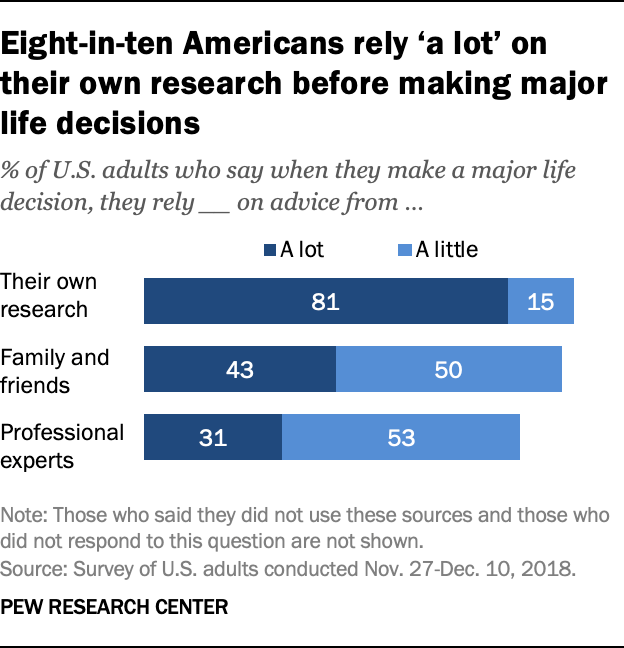Outline some significant characteristics in this image. According to a survey, 84% of adults in the United States rely on professional experts for guidance when making important life decisions. A recent survey conducted in the United States revealed that 43% of adults rely heavily on their family and friends for advice when making major life decisions. 